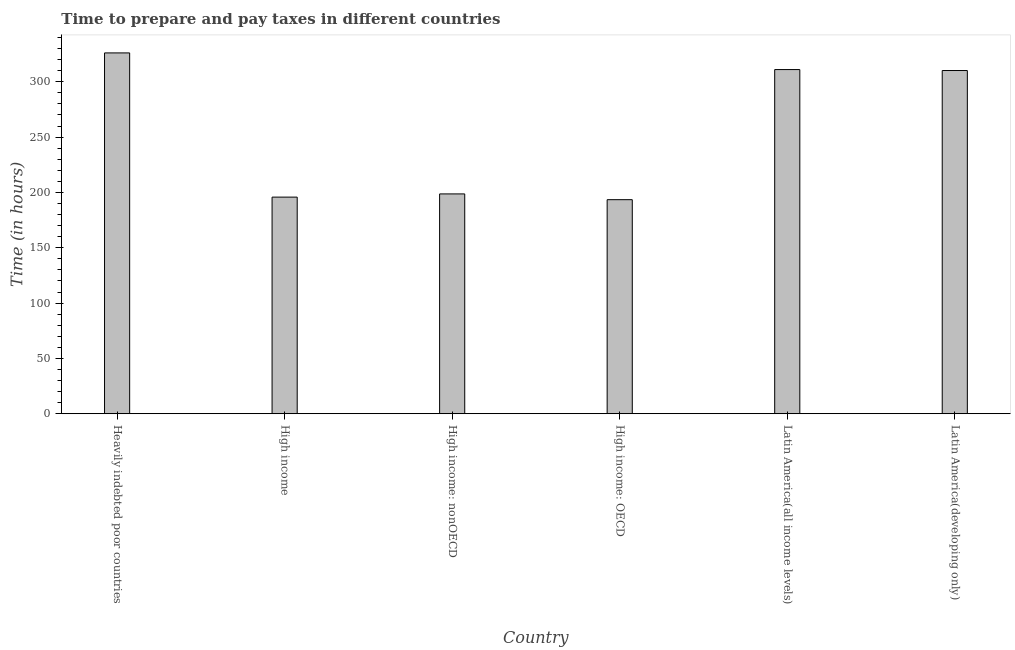Does the graph contain any zero values?
Keep it short and to the point. No. What is the title of the graph?
Give a very brief answer. Time to prepare and pay taxes in different countries. What is the label or title of the X-axis?
Your answer should be very brief. Country. What is the label or title of the Y-axis?
Offer a terse response. Time (in hours). What is the time to prepare and pay taxes in Heavily indebted poor countries?
Your response must be concise. 326.05. Across all countries, what is the maximum time to prepare and pay taxes?
Offer a terse response. 326.05. Across all countries, what is the minimum time to prepare and pay taxes?
Your answer should be compact. 193.43. In which country was the time to prepare and pay taxes maximum?
Your answer should be compact. Heavily indebted poor countries. In which country was the time to prepare and pay taxes minimum?
Your answer should be compact. High income: OECD. What is the sum of the time to prepare and pay taxes?
Offer a very short reply. 1535.02. What is the difference between the time to prepare and pay taxes in High income and Latin America(all income levels)?
Your answer should be very brief. -115.25. What is the average time to prepare and pay taxes per country?
Make the answer very short. 255.84. What is the median time to prepare and pay taxes?
Offer a very short reply. 254.39. What is the ratio of the time to prepare and pay taxes in High income: OECD to that in High income: nonOECD?
Your answer should be compact. 0.97. Is the time to prepare and pay taxes in Heavily indebted poor countries less than that in High income?
Provide a succinct answer. No. What is the difference between the highest and the second highest time to prepare and pay taxes?
Your answer should be compact. 15.05. Is the sum of the time to prepare and pay taxes in High income: OECD and High income: nonOECD greater than the maximum time to prepare and pay taxes across all countries?
Make the answer very short. Yes. What is the difference between the highest and the lowest time to prepare and pay taxes?
Offer a terse response. 132.62. How many bars are there?
Your answer should be very brief. 6. How many countries are there in the graph?
Provide a short and direct response. 6. What is the Time (in hours) in Heavily indebted poor countries?
Your answer should be compact. 326.05. What is the Time (in hours) of High income?
Give a very brief answer. 195.75. What is the Time (in hours) in High income: nonOECD?
Your answer should be very brief. 198.65. What is the Time (in hours) of High income: OECD?
Your response must be concise. 193.43. What is the Time (in hours) of Latin America(all income levels)?
Make the answer very short. 311. What is the Time (in hours) of Latin America(developing only)?
Offer a terse response. 310.14. What is the difference between the Time (in hours) in Heavily indebted poor countries and High income?
Give a very brief answer. 130.3. What is the difference between the Time (in hours) in Heavily indebted poor countries and High income: nonOECD?
Your answer should be very brief. 127.41. What is the difference between the Time (in hours) in Heavily indebted poor countries and High income: OECD?
Provide a succinct answer. 132.62. What is the difference between the Time (in hours) in Heavily indebted poor countries and Latin America(all income levels)?
Your answer should be compact. 15.05. What is the difference between the Time (in hours) in Heavily indebted poor countries and Latin America(developing only)?
Make the answer very short. 15.91. What is the difference between the Time (in hours) in High income and High income: nonOECD?
Provide a short and direct response. -2.9. What is the difference between the Time (in hours) in High income and High income: OECD?
Provide a succinct answer. 2.32. What is the difference between the Time (in hours) in High income and Latin America(all income levels)?
Your answer should be very brief. -115.25. What is the difference between the Time (in hours) in High income and Latin America(developing only)?
Offer a terse response. -114.39. What is the difference between the Time (in hours) in High income: nonOECD and High income: OECD?
Your answer should be compact. 5.21. What is the difference between the Time (in hours) in High income: nonOECD and Latin America(all income levels)?
Offer a very short reply. -112.35. What is the difference between the Time (in hours) in High income: nonOECD and Latin America(developing only)?
Offer a very short reply. -111.5. What is the difference between the Time (in hours) in High income: OECD and Latin America(all income levels)?
Provide a succinct answer. -117.57. What is the difference between the Time (in hours) in High income: OECD and Latin America(developing only)?
Make the answer very short. -116.71. What is the difference between the Time (in hours) in Latin America(all income levels) and Latin America(developing only)?
Your answer should be very brief. 0.86. What is the ratio of the Time (in hours) in Heavily indebted poor countries to that in High income?
Keep it short and to the point. 1.67. What is the ratio of the Time (in hours) in Heavily indebted poor countries to that in High income: nonOECD?
Give a very brief answer. 1.64. What is the ratio of the Time (in hours) in Heavily indebted poor countries to that in High income: OECD?
Your answer should be very brief. 1.69. What is the ratio of the Time (in hours) in Heavily indebted poor countries to that in Latin America(all income levels)?
Offer a terse response. 1.05. What is the ratio of the Time (in hours) in Heavily indebted poor countries to that in Latin America(developing only)?
Ensure brevity in your answer.  1.05. What is the ratio of the Time (in hours) in High income to that in High income: nonOECD?
Your answer should be very brief. 0.98. What is the ratio of the Time (in hours) in High income to that in Latin America(all income levels)?
Your answer should be very brief. 0.63. What is the ratio of the Time (in hours) in High income to that in Latin America(developing only)?
Ensure brevity in your answer.  0.63. What is the ratio of the Time (in hours) in High income: nonOECD to that in High income: OECD?
Ensure brevity in your answer.  1.03. What is the ratio of the Time (in hours) in High income: nonOECD to that in Latin America(all income levels)?
Offer a very short reply. 0.64. What is the ratio of the Time (in hours) in High income: nonOECD to that in Latin America(developing only)?
Your answer should be compact. 0.64. What is the ratio of the Time (in hours) in High income: OECD to that in Latin America(all income levels)?
Your response must be concise. 0.62. What is the ratio of the Time (in hours) in High income: OECD to that in Latin America(developing only)?
Offer a very short reply. 0.62. 